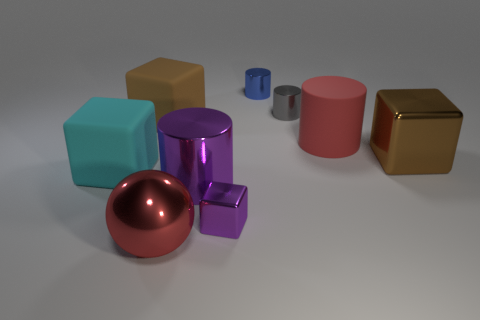What number of objects are either red metallic spheres or shiny objects on the left side of the gray metallic object?
Keep it short and to the point. 4. There is a rubber cube that is behind the big cyan matte block; are there any brown metal cubes that are behind it?
Offer a very short reply. No. What shape is the matte object that is in front of the big brown object on the right side of the big brown rubber block on the right side of the big cyan rubber cube?
Offer a terse response. Cube. What is the color of the block that is on the right side of the large cyan matte thing and in front of the large brown metal object?
Offer a terse response. Purple. There is a tiny shiny object that is in front of the large matte cylinder; what is its shape?
Offer a terse response. Cube. There is a big brown object that is made of the same material as the blue cylinder; what is its shape?
Your response must be concise. Cube. What number of matte things are blue cylinders or big green spheres?
Offer a terse response. 0. There is a rubber cube behind the matte object right of the ball; what number of rubber things are on the left side of it?
Keep it short and to the point. 1. Does the metallic cylinder on the left side of the blue object have the same size as the metal cylinder on the right side of the tiny blue metallic cylinder?
Ensure brevity in your answer.  No. What material is the red thing that is the same shape as the blue metallic object?
Ensure brevity in your answer.  Rubber. 